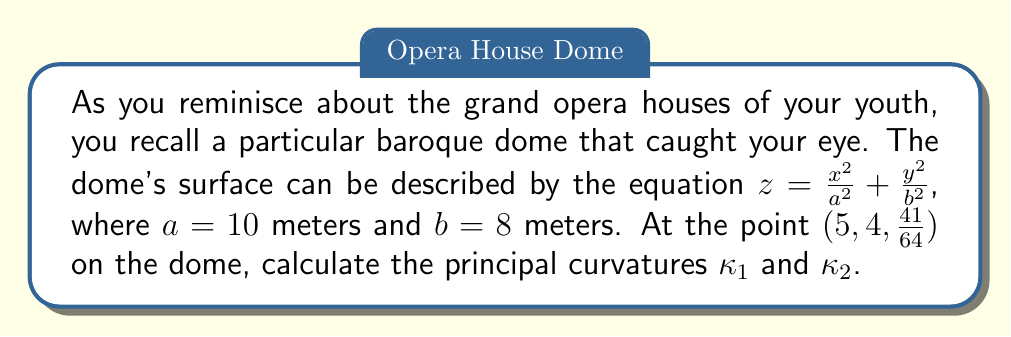Teach me how to tackle this problem. Let's approach this step-by-step:

1) For a surface described by $z = f(x,y)$, the principal curvatures are given by:

   $$\kappa_{1,2} = H \pm \sqrt{H^2 - K}$$

   where $H$ is the mean curvature and $K$ is the Gaussian curvature.

2) To find $H$ and $K$, we need to calculate the first and second fundamental forms.

3) First, let's compute the partial derivatives:

   $f_x = \frac{2x}{a^2} = \frac{x}{50}$
   $f_y = \frac{2y}{b^2} = \frac{y}{32}$
   $f_{xx} = \frac{2}{a^2} = \frac{1}{50}$
   $f_{yy} = \frac{2}{b^2} = \frac{1}{32}$
   $f_{xy} = 0$

4) Now, we can calculate $E$, $F$, $G$, $L$, $M$, $N$:

   $E = 1 + f_x^2 = 1 + (\frac{5}{50})^2 = \frac{2601}{2500}$
   $F = f_x f_y = \frac{5}{50} \cdot \frac{4}{32} = \frac{1}{80}$
   $G = 1 + f_y^2 = 1 + (\frac{4}{32})^2 = \frac{1025}{1024}$
   $L = \frac{f_{xx}}{\sqrt{1+f_x^2+f_y^2}} = \frac{1/50}{\sqrt{1+(\frac{5}{50})^2+(\frac{4}{32})^2}} = \frac{1}{50\sqrt{\frac{2666441}{2560000}}}$
   $M = \frac{f_{xy}}{\sqrt{1+f_x^2+f_y^2}} = 0$
   $N = \frac{f_{yy}}{\sqrt{1+f_x^2+f_y^2}} = \frac{1/32}{\sqrt{1+(\frac{5}{50})^2+(\frac{4}{32})^2}} = \frac{1}{32\sqrt{\frac{2666441}{2560000}}}$

5) The Gaussian curvature $K$ is:

   $$K = \frac{LN-M^2}{EG-F^2} = \frac{(\frac{1}{50\sqrt{\frac{2666441}{2560000}}})(\frac{1}{32\sqrt{\frac{2666441}{2560000}}})-(0)^2}{\frac{2601}{2500}\cdot\frac{1025}{1024}-(\frac{1}{80})^2} = \frac{1}{3200}$$

6) The mean curvature $H$ is:

   $$H = \frac{EN+GL-2FM}{2(EG-F^2)} = \frac{\frac{2601}{2500}\cdot\frac{1}{32\sqrt{\frac{2666441}{2560000}}}+\frac{1025}{1024}\cdot\frac{1}{50\sqrt{\frac{2666441}{2560000}}}-2\cdot\frac{1}{80}\cdot0}{2(\frac{2601}{2500}\cdot\frac{1025}{1024}-(\frac{1}{80})^2)} = \frac{41}{3200}$$

7) Now we can calculate the principal curvatures:

   $$\kappa_{1,2} = H \pm \sqrt{H^2 - K} = \frac{41}{3200} \pm \sqrt{(\frac{41}{3200})^2 - \frac{1}{3200}}$$

8) Simplifying:

   $$\kappa_1 = \frac{41}{3200} + \frac{1}{40} = \frac{81}{3200}$$
   $$\kappa_2 = \frac{41}{3200} - \frac{1}{40} = \frac{1}{3200}$$
Answer: $\kappa_1 = \frac{81}{3200}$, $\kappa_2 = \frac{1}{3200}$ 